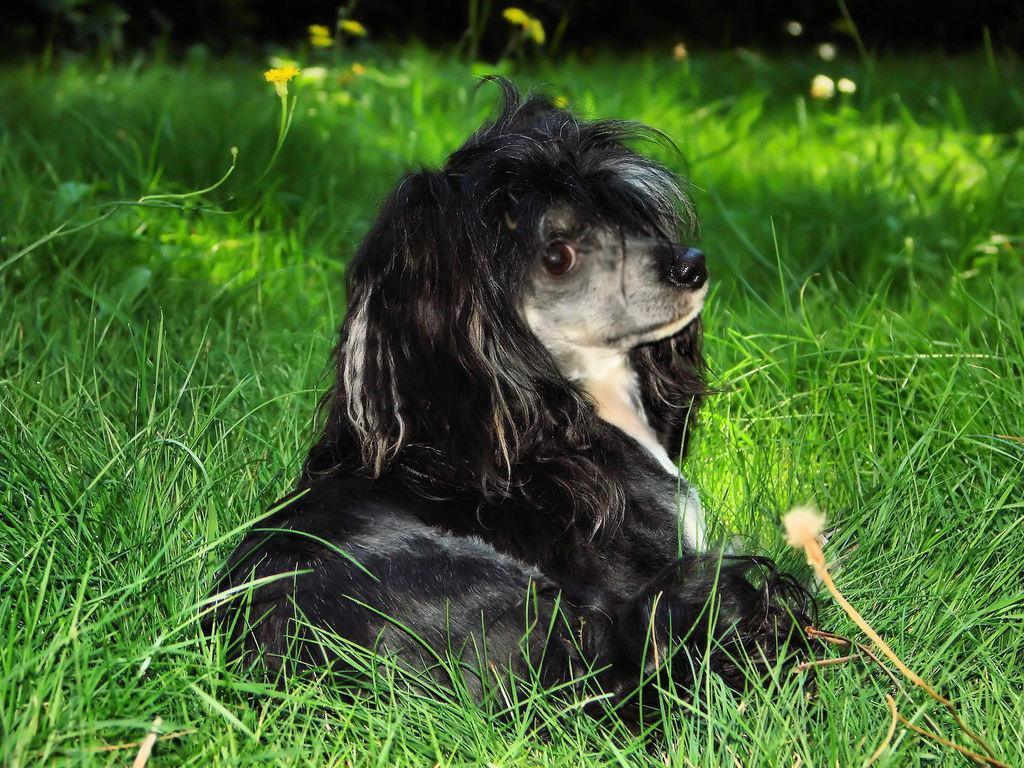Can you describe this image briefly? In the image there is a black and white color dog on the ground. There is grass and yellow colored flowers are on the ground.  